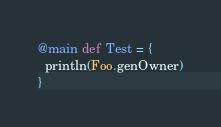<code> <loc_0><loc_0><loc_500><loc_500><_Scala_>@main def Test = {
  println(Foo.genOwner)
}</code> 